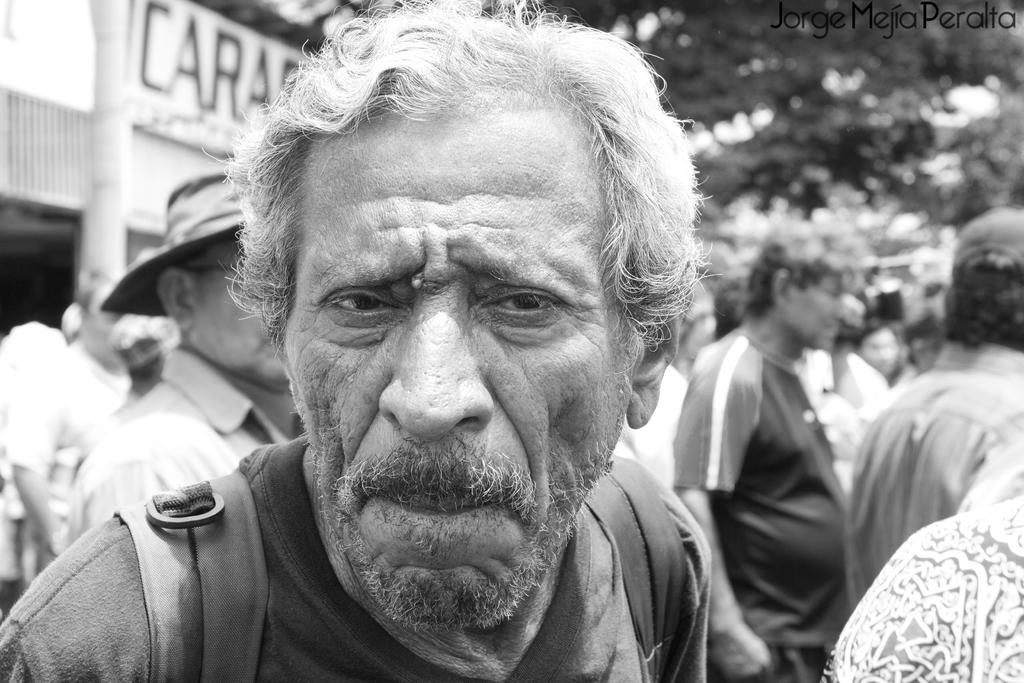Who is the main subject in the image? There is a man in the center of the image. What is the man wearing? The man is wearing a bag. What can be seen in the background of the image? There are people, trees, and a building in the background of the image. What type of zebra can be seen in the image? There is no zebra present in the image. What hope does the man in the image have for the future? The image does not provide any information about the man's hopes or future plans. 